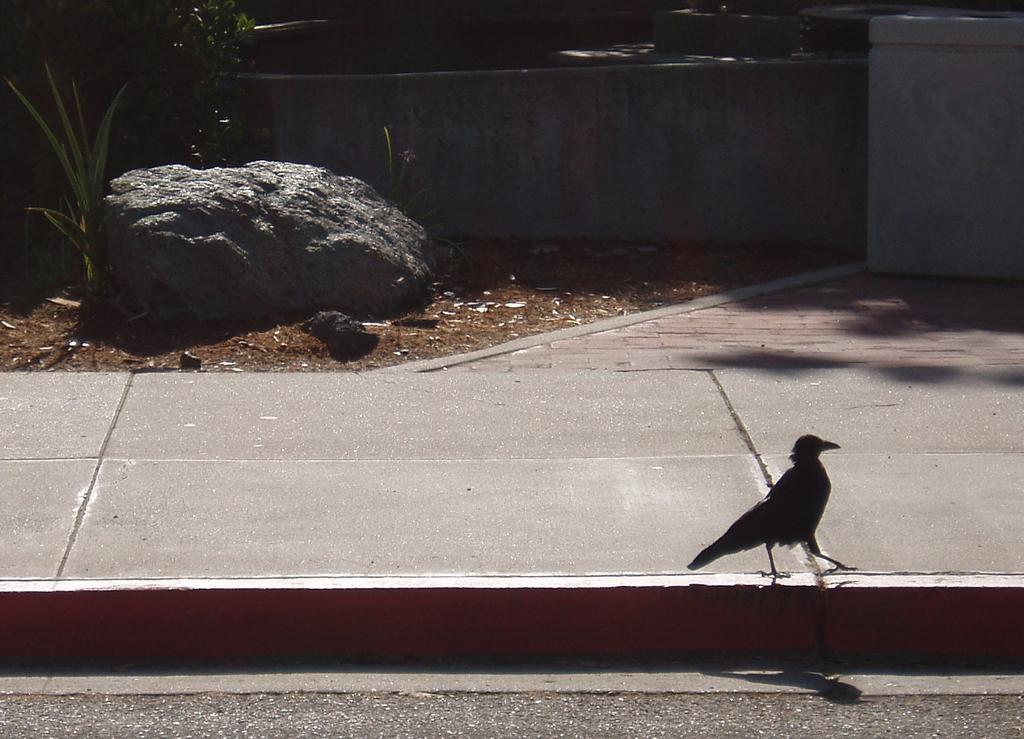Describe this image in one or two sentences. In this image in front there is a bird. In the center of the image there is a road. In the background of the image there is a wall. There is a rock. There are plants. 